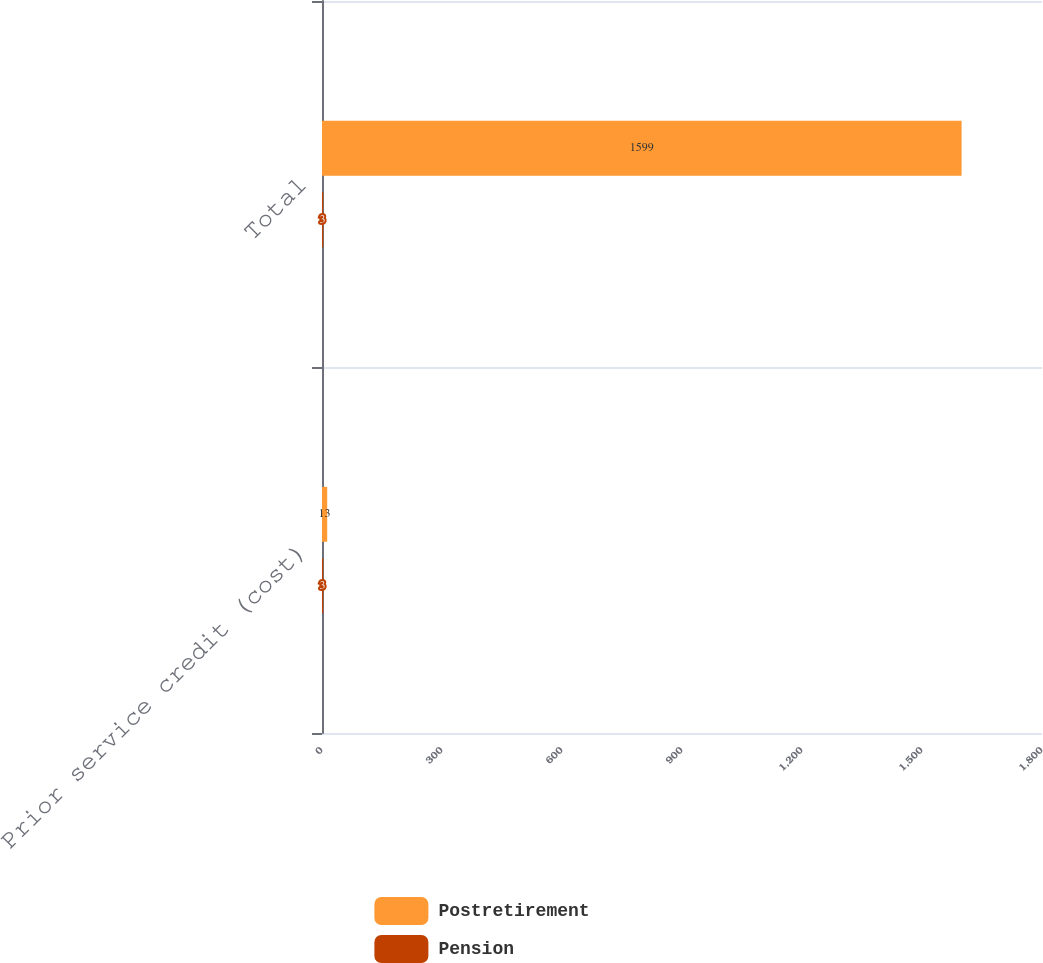Convert chart. <chart><loc_0><loc_0><loc_500><loc_500><stacked_bar_chart><ecel><fcel>Prior service credit (cost)<fcel>Total<nl><fcel>Postretirement<fcel>13<fcel>1599<nl><fcel>Pension<fcel>3<fcel>3<nl></chart> 